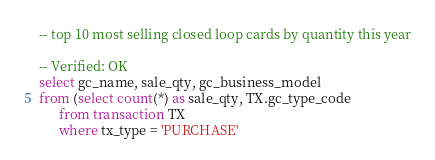<code> <loc_0><loc_0><loc_500><loc_500><_SQL_>-- top 10 most selling closed loop cards by quantity this year

-- Verified: OK
select gc_name, sale_qty, gc_business_model
from (select count(*) as sale_qty, TX.gc_type_code
      from transaction TX
      where tx_type = 'PURCHASE'</code> 